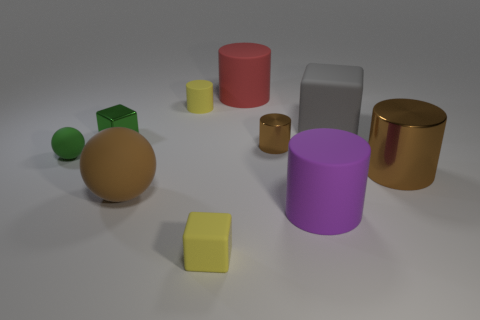How does the lighting affect the appearance of the colors in the image? The lighting in the image appears to be coming from above and slightly to the right, casting gentle shadows on the left sides of the objects. This highlights the textures and gives a soft glow that could slightly alter the perception of their colors, making them appear richer and deeper. 